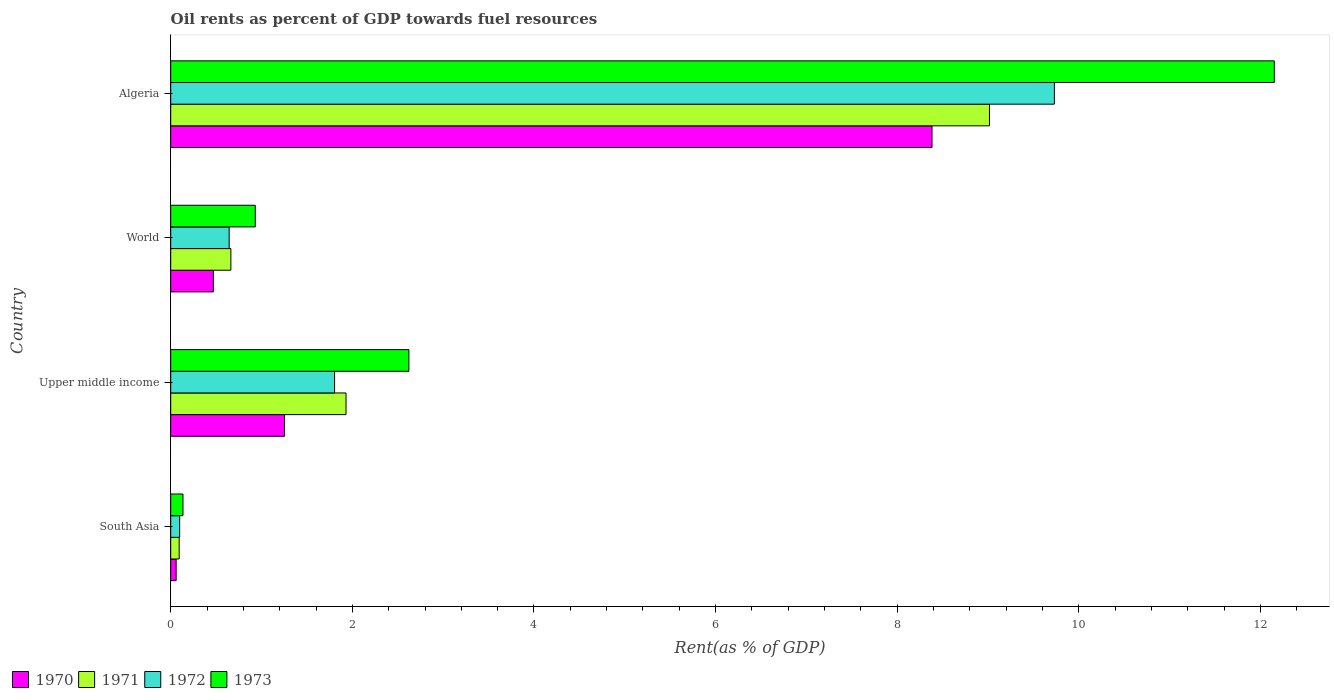Are the number of bars on each tick of the Y-axis equal?
Give a very brief answer. Yes. How many bars are there on the 4th tick from the bottom?
Your answer should be very brief. 4. What is the label of the 1st group of bars from the top?
Offer a terse response. Algeria. In how many cases, is the number of bars for a given country not equal to the number of legend labels?
Make the answer very short. 0. What is the oil rent in 1971 in World?
Make the answer very short. 0.66. Across all countries, what is the maximum oil rent in 1972?
Your answer should be very brief. 9.73. Across all countries, what is the minimum oil rent in 1973?
Ensure brevity in your answer.  0.14. In which country was the oil rent in 1970 maximum?
Keep it short and to the point. Algeria. What is the total oil rent in 1970 in the graph?
Offer a terse response. 10.17. What is the difference between the oil rent in 1971 in South Asia and that in World?
Provide a succinct answer. -0.57. What is the difference between the oil rent in 1971 in World and the oil rent in 1973 in Upper middle income?
Your response must be concise. -1.96. What is the average oil rent in 1973 per country?
Ensure brevity in your answer.  3.96. What is the difference between the oil rent in 1972 and oil rent in 1973 in Upper middle income?
Provide a short and direct response. -0.82. In how many countries, is the oil rent in 1970 greater than 10 %?
Offer a terse response. 0. What is the ratio of the oil rent in 1973 in Algeria to that in World?
Your answer should be very brief. 13.05. Is the difference between the oil rent in 1972 in South Asia and World greater than the difference between the oil rent in 1973 in South Asia and World?
Offer a very short reply. Yes. What is the difference between the highest and the second highest oil rent in 1971?
Keep it short and to the point. 7.09. What is the difference between the highest and the lowest oil rent in 1972?
Your response must be concise. 9.63. Is the sum of the oil rent in 1971 in South Asia and World greater than the maximum oil rent in 1972 across all countries?
Give a very brief answer. No. What does the 1st bar from the top in World represents?
Offer a terse response. 1973. How many bars are there?
Provide a succinct answer. 16. How many countries are there in the graph?
Your response must be concise. 4. Where does the legend appear in the graph?
Provide a short and direct response. Bottom left. How many legend labels are there?
Keep it short and to the point. 4. How are the legend labels stacked?
Keep it short and to the point. Horizontal. What is the title of the graph?
Offer a terse response. Oil rents as percent of GDP towards fuel resources. What is the label or title of the X-axis?
Make the answer very short. Rent(as % of GDP). What is the label or title of the Y-axis?
Your answer should be compact. Country. What is the Rent(as % of GDP) of 1970 in South Asia?
Offer a terse response. 0.06. What is the Rent(as % of GDP) in 1971 in South Asia?
Provide a short and direct response. 0.09. What is the Rent(as % of GDP) of 1972 in South Asia?
Give a very brief answer. 0.1. What is the Rent(as % of GDP) in 1973 in South Asia?
Provide a short and direct response. 0.14. What is the Rent(as % of GDP) in 1970 in Upper middle income?
Your answer should be very brief. 1.25. What is the Rent(as % of GDP) in 1971 in Upper middle income?
Make the answer very short. 1.93. What is the Rent(as % of GDP) in 1972 in Upper middle income?
Your answer should be compact. 1.8. What is the Rent(as % of GDP) in 1973 in Upper middle income?
Give a very brief answer. 2.62. What is the Rent(as % of GDP) in 1970 in World?
Give a very brief answer. 0.47. What is the Rent(as % of GDP) of 1971 in World?
Your answer should be very brief. 0.66. What is the Rent(as % of GDP) in 1972 in World?
Your answer should be compact. 0.64. What is the Rent(as % of GDP) of 1973 in World?
Your response must be concise. 0.93. What is the Rent(as % of GDP) of 1970 in Algeria?
Offer a very short reply. 8.38. What is the Rent(as % of GDP) in 1971 in Algeria?
Offer a terse response. 9.02. What is the Rent(as % of GDP) of 1972 in Algeria?
Offer a very short reply. 9.73. What is the Rent(as % of GDP) of 1973 in Algeria?
Your answer should be very brief. 12.15. Across all countries, what is the maximum Rent(as % of GDP) in 1970?
Your response must be concise. 8.38. Across all countries, what is the maximum Rent(as % of GDP) in 1971?
Make the answer very short. 9.02. Across all countries, what is the maximum Rent(as % of GDP) of 1972?
Keep it short and to the point. 9.73. Across all countries, what is the maximum Rent(as % of GDP) of 1973?
Make the answer very short. 12.15. Across all countries, what is the minimum Rent(as % of GDP) in 1970?
Make the answer very short. 0.06. Across all countries, what is the minimum Rent(as % of GDP) of 1971?
Ensure brevity in your answer.  0.09. Across all countries, what is the minimum Rent(as % of GDP) of 1972?
Your answer should be compact. 0.1. Across all countries, what is the minimum Rent(as % of GDP) in 1973?
Provide a succinct answer. 0.14. What is the total Rent(as % of GDP) of 1970 in the graph?
Offer a terse response. 10.17. What is the total Rent(as % of GDP) in 1971 in the graph?
Make the answer very short. 11.7. What is the total Rent(as % of GDP) of 1972 in the graph?
Your answer should be compact. 12.28. What is the total Rent(as % of GDP) in 1973 in the graph?
Your answer should be compact. 15.84. What is the difference between the Rent(as % of GDP) in 1970 in South Asia and that in Upper middle income?
Ensure brevity in your answer.  -1.19. What is the difference between the Rent(as % of GDP) of 1971 in South Asia and that in Upper middle income?
Your answer should be compact. -1.84. What is the difference between the Rent(as % of GDP) of 1972 in South Asia and that in Upper middle income?
Make the answer very short. -1.71. What is the difference between the Rent(as % of GDP) in 1973 in South Asia and that in Upper middle income?
Your answer should be compact. -2.49. What is the difference between the Rent(as % of GDP) of 1970 in South Asia and that in World?
Ensure brevity in your answer.  -0.41. What is the difference between the Rent(as % of GDP) of 1971 in South Asia and that in World?
Provide a short and direct response. -0.57. What is the difference between the Rent(as % of GDP) in 1972 in South Asia and that in World?
Provide a succinct answer. -0.55. What is the difference between the Rent(as % of GDP) of 1973 in South Asia and that in World?
Your response must be concise. -0.8. What is the difference between the Rent(as % of GDP) of 1970 in South Asia and that in Algeria?
Ensure brevity in your answer.  -8.32. What is the difference between the Rent(as % of GDP) of 1971 in South Asia and that in Algeria?
Provide a succinct answer. -8.92. What is the difference between the Rent(as % of GDP) of 1972 in South Asia and that in Algeria?
Make the answer very short. -9.63. What is the difference between the Rent(as % of GDP) in 1973 in South Asia and that in Algeria?
Give a very brief answer. -12.02. What is the difference between the Rent(as % of GDP) of 1970 in Upper middle income and that in World?
Keep it short and to the point. 0.78. What is the difference between the Rent(as % of GDP) in 1971 in Upper middle income and that in World?
Provide a short and direct response. 1.27. What is the difference between the Rent(as % of GDP) of 1972 in Upper middle income and that in World?
Give a very brief answer. 1.16. What is the difference between the Rent(as % of GDP) of 1973 in Upper middle income and that in World?
Your response must be concise. 1.69. What is the difference between the Rent(as % of GDP) of 1970 in Upper middle income and that in Algeria?
Provide a short and direct response. -7.13. What is the difference between the Rent(as % of GDP) in 1971 in Upper middle income and that in Algeria?
Your answer should be very brief. -7.09. What is the difference between the Rent(as % of GDP) of 1972 in Upper middle income and that in Algeria?
Keep it short and to the point. -7.93. What is the difference between the Rent(as % of GDP) of 1973 in Upper middle income and that in Algeria?
Provide a succinct answer. -9.53. What is the difference between the Rent(as % of GDP) of 1970 in World and that in Algeria?
Your answer should be very brief. -7.91. What is the difference between the Rent(as % of GDP) of 1971 in World and that in Algeria?
Offer a very short reply. -8.35. What is the difference between the Rent(as % of GDP) in 1972 in World and that in Algeria?
Keep it short and to the point. -9.09. What is the difference between the Rent(as % of GDP) of 1973 in World and that in Algeria?
Provide a short and direct response. -11.22. What is the difference between the Rent(as % of GDP) of 1970 in South Asia and the Rent(as % of GDP) of 1971 in Upper middle income?
Your answer should be very brief. -1.87. What is the difference between the Rent(as % of GDP) of 1970 in South Asia and the Rent(as % of GDP) of 1972 in Upper middle income?
Your answer should be very brief. -1.74. What is the difference between the Rent(as % of GDP) of 1970 in South Asia and the Rent(as % of GDP) of 1973 in Upper middle income?
Keep it short and to the point. -2.56. What is the difference between the Rent(as % of GDP) in 1971 in South Asia and the Rent(as % of GDP) in 1972 in Upper middle income?
Your answer should be very brief. -1.71. What is the difference between the Rent(as % of GDP) in 1971 in South Asia and the Rent(as % of GDP) in 1973 in Upper middle income?
Ensure brevity in your answer.  -2.53. What is the difference between the Rent(as % of GDP) in 1972 in South Asia and the Rent(as % of GDP) in 1973 in Upper middle income?
Provide a succinct answer. -2.52. What is the difference between the Rent(as % of GDP) of 1970 in South Asia and the Rent(as % of GDP) of 1971 in World?
Your answer should be very brief. -0.6. What is the difference between the Rent(as % of GDP) in 1970 in South Asia and the Rent(as % of GDP) in 1972 in World?
Give a very brief answer. -0.58. What is the difference between the Rent(as % of GDP) of 1970 in South Asia and the Rent(as % of GDP) of 1973 in World?
Provide a short and direct response. -0.87. What is the difference between the Rent(as % of GDP) of 1971 in South Asia and the Rent(as % of GDP) of 1972 in World?
Give a very brief answer. -0.55. What is the difference between the Rent(as % of GDP) of 1971 in South Asia and the Rent(as % of GDP) of 1973 in World?
Your answer should be compact. -0.84. What is the difference between the Rent(as % of GDP) of 1972 in South Asia and the Rent(as % of GDP) of 1973 in World?
Provide a succinct answer. -0.83. What is the difference between the Rent(as % of GDP) in 1970 in South Asia and the Rent(as % of GDP) in 1971 in Algeria?
Give a very brief answer. -8.96. What is the difference between the Rent(as % of GDP) in 1970 in South Asia and the Rent(as % of GDP) in 1972 in Algeria?
Give a very brief answer. -9.67. What is the difference between the Rent(as % of GDP) of 1970 in South Asia and the Rent(as % of GDP) of 1973 in Algeria?
Provide a short and direct response. -12.09. What is the difference between the Rent(as % of GDP) of 1971 in South Asia and the Rent(as % of GDP) of 1972 in Algeria?
Keep it short and to the point. -9.64. What is the difference between the Rent(as % of GDP) in 1971 in South Asia and the Rent(as % of GDP) in 1973 in Algeria?
Offer a very short reply. -12.06. What is the difference between the Rent(as % of GDP) in 1972 in South Asia and the Rent(as % of GDP) in 1973 in Algeria?
Your response must be concise. -12.05. What is the difference between the Rent(as % of GDP) of 1970 in Upper middle income and the Rent(as % of GDP) of 1971 in World?
Keep it short and to the point. 0.59. What is the difference between the Rent(as % of GDP) of 1970 in Upper middle income and the Rent(as % of GDP) of 1972 in World?
Offer a terse response. 0.61. What is the difference between the Rent(as % of GDP) in 1970 in Upper middle income and the Rent(as % of GDP) in 1973 in World?
Ensure brevity in your answer.  0.32. What is the difference between the Rent(as % of GDP) of 1971 in Upper middle income and the Rent(as % of GDP) of 1972 in World?
Provide a succinct answer. 1.29. What is the difference between the Rent(as % of GDP) in 1972 in Upper middle income and the Rent(as % of GDP) in 1973 in World?
Provide a short and direct response. 0.87. What is the difference between the Rent(as % of GDP) of 1970 in Upper middle income and the Rent(as % of GDP) of 1971 in Algeria?
Give a very brief answer. -7.76. What is the difference between the Rent(as % of GDP) of 1970 in Upper middle income and the Rent(as % of GDP) of 1972 in Algeria?
Your response must be concise. -8.48. What is the difference between the Rent(as % of GDP) of 1970 in Upper middle income and the Rent(as % of GDP) of 1973 in Algeria?
Provide a succinct answer. -10.9. What is the difference between the Rent(as % of GDP) in 1971 in Upper middle income and the Rent(as % of GDP) in 1972 in Algeria?
Ensure brevity in your answer.  -7.8. What is the difference between the Rent(as % of GDP) of 1971 in Upper middle income and the Rent(as % of GDP) of 1973 in Algeria?
Your answer should be compact. -10.22. What is the difference between the Rent(as % of GDP) in 1972 in Upper middle income and the Rent(as % of GDP) in 1973 in Algeria?
Provide a short and direct response. -10.35. What is the difference between the Rent(as % of GDP) in 1970 in World and the Rent(as % of GDP) in 1971 in Algeria?
Ensure brevity in your answer.  -8.55. What is the difference between the Rent(as % of GDP) of 1970 in World and the Rent(as % of GDP) of 1972 in Algeria?
Offer a very short reply. -9.26. What is the difference between the Rent(as % of GDP) in 1970 in World and the Rent(as % of GDP) in 1973 in Algeria?
Keep it short and to the point. -11.68. What is the difference between the Rent(as % of GDP) in 1971 in World and the Rent(as % of GDP) in 1972 in Algeria?
Offer a very short reply. -9.07. What is the difference between the Rent(as % of GDP) of 1971 in World and the Rent(as % of GDP) of 1973 in Algeria?
Your answer should be very brief. -11.49. What is the difference between the Rent(as % of GDP) of 1972 in World and the Rent(as % of GDP) of 1973 in Algeria?
Give a very brief answer. -11.51. What is the average Rent(as % of GDP) in 1970 per country?
Provide a succinct answer. 2.54. What is the average Rent(as % of GDP) of 1971 per country?
Ensure brevity in your answer.  2.93. What is the average Rent(as % of GDP) in 1972 per country?
Your answer should be very brief. 3.07. What is the average Rent(as % of GDP) in 1973 per country?
Offer a very short reply. 3.96. What is the difference between the Rent(as % of GDP) of 1970 and Rent(as % of GDP) of 1971 in South Asia?
Make the answer very short. -0.03. What is the difference between the Rent(as % of GDP) in 1970 and Rent(as % of GDP) in 1972 in South Asia?
Ensure brevity in your answer.  -0.04. What is the difference between the Rent(as % of GDP) of 1970 and Rent(as % of GDP) of 1973 in South Asia?
Your response must be concise. -0.08. What is the difference between the Rent(as % of GDP) of 1971 and Rent(as % of GDP) of 1972 in South Asia?
Your answer should be compact. -0.01. What is the difference between the Rent(as % of GDP) of 1971 and Rent(as % of GDP) of 1973 in South Asia?
Your answer should be very brief. -0.04. What is the difference between the Rent(as % of GDP) in 1972 and Rent(as % of GDP) in 1973 in South Asia?
Your answer should be compact. -0.04. What is the difference between the Rent(as % of GDP) in 1970 and Rent(as % of GDP) in 1971 in Upper middle income?
Keep it short and to the point. -0.68. What is the difference between the Rent(as % of GDP) in 1970 and Rent(as % of GDP) in 1972 in Upper middle income?
Ensure brevity in your answer.  -0.55. What is the difference between the Rent(as % of GDP) in 1970 and Rent(as % of GDP) in 1973 in Upper middle income?
Offer a very short reply. -1.37. What is the difference between the Rent(as % of GDP) of 1971 and Rent(as % of GDP) of 1972 in Upper middle income?
Keep it short and to the point. 0.13. What is the difference between the Rent(as % of GDP) in 1971 and Rent(as % of GDP) in 1973 in Upper middle income?
Provide a succinct answer. -0.69. What is the difference between the Rent(as % of GDP) of 1972 and Rent(as % of GDP) of 1973 in Upper middle income?
Offer a terse response. -0.82. What is the difference between the Rent(as % of GDP) of 1970 and Rent(as % of GDP) of 1971 in World?
Make the answer very short. -0.19. What is the difference between the Rent(as % of GDP) of 1970 and Rent(as % of GDP) of 1972 in World?
Keep it short and to the point. -0.17. What is the difference between the Rent(as % of GDP) in 1970 and Rent(as % of GDP) in 1973 in World?
Provide a succinct answer. -0.46. What is the difference between the Rent(as % of GDP) of 1971 and Rent(as % of GDP) of 1972 in World?
Keep it short and to the point. 0.02. What is the difference between the Rent(as % of GDP) of 1971 and Rent(as % of GDP) of 1973 in World?
Your answer should be very brief. -0.27. What is the difference between the Rent(as % of GDP) of 1972 and Rent(as % of GDP) of 1973 in World?
Make the answer very short. -0.29. What is the difference between the Rent(as % of GDP) in 1970 and Rent(as % of GDP) in 1971 in Algeria?
Your response must be concise. -0.63. What is the difference between the Rent(as % of GDP) in 1970 and Rent(as % of GDP) in 1972 in Algeria?
Offer a very short reply. -1.35. What is the difference between the Rent(as % of GDP) of 1970 and Rent(as % of GDP) of 1973 in Algeria?
Your response must be concise. -3.77. What is the difference between the Rent(as % of GDP) in 1971 and Rent(as % of GDP) in 1972 in Algeria?
Offer a terse response. -0.71. What is the difference between the Rent(as % of GDP) of 1971 and Rent(as % of GDP) of 1973 in Algeria?
Keep it short and to the point. -3.14. What is the difference between the Rent(as % of GDP) in 1972 and Rent(as % of GDP) in 1973 in Algeria?
Keep it short and to the point. -2.42. What is the ratio of the Rent(as % of GDP) of 1970 in South Asia to that in Upper middle income?
Offer a very short reply. 0.05. What is the ratio of the Rent(as % of GDP) in 1971 in South Asia to that in Upper middle income?
Your response must be concise. 0.05. What is the ratio of the Rent(as % of GDP) in 1972 in South Asia to that in Upper middle income?
Offer a terse response. 0.05. What is the ratio of the Rent(as % of GDP) of 1973 in South Asia to that in Upper middle income?
Give a very brief answer. 0.05. What is the ratio of the Rent(as % of GDP) of 1970 in South Asia to that in World?
Provide a short and direct response. 0.13. What is the ratio of the Rent(as % of GDP) in 1971 in South Asia to that in World?
Provide a succinct answer. 0.14. What is the ratio of the Rent(as % of GDP) in 1972 in South Asia to that in World?
Keep it short and to the point. 0.15. What is the ratio of the Rent(as % of GDP) of 1973 in South Asia to that in World?
Give a very brief answer. 0.14. What is the ratio of the Rent(as % of GDP) of 1970 in South Asia to that in Algeria?
Offer a very short reply. 0.01. What is the ratio of the Rent(as % of GDP) of 1971 in South Asia to that in Algeria?
Offer a terse response. 0.01. What is the ratio of the Rent(as % of GDP) in 1972 in South Asia to that in Algeria?
Provide a succinct answer. 0.01. What is the ratio of the Rent(as % of GDP) in 1973 in South Asia to that in Algeria?
Provide a short and direct response. 0.01. What is the ratio of the Rent(as % of GDP) in 1970 in Upper middle income to that in World?
Your answer should be compact. 2.67. What is the ratio of the Rent(as % of GDP) in 1971 in Upper middle income to that in World?
Offer a terse response. 2.91. What is the ratio of the Rent(as % of GDP) of 1972 in Upper middle income to that in World?
Ensure brevity in your answer.  2.8. What is the ratio of the Rent(as % of GDP) of 1973 in Upper middle income to that in World?
Provide a succinct answer. 2.82. What is the ratio of the Rent(as % of GDP) of 1970 in Upper middle income to that in Algeria?
Your answer should be very brief. 0.15. What is the ratio of the Rent(as % of GDP) of 1971 in Upper middle income to that in Algeria?
Your response must be concise. 0.21. What is the ratio of the Rent(as % of GDP) of 1972 in Upper middle income to that in Algeria?
Keep it short and to the point. 0.19. What is the ratio of the Rent(as % of GDP) in 1973 in Upper middle income to that in Algeria?
Your response must be concise. 0.22. What is the ratio of the Rent(as % of GDP) in 1970 in World to that in Algeria?
Offer a terse response. 0.06. What is the ratio of the Rent(as % of GDP) of 1971 in World to that in Algeria?
Provide a short and direct response. 0.07. What is the ratio of the Rent(as % of GDP) in 1972 in World to that in Algeria?
Your answer should be compact. 0.07. What is the ratio of the Rent(as % of GDP) of 1973 in World to that in Algeria?
Your answer should be compact. 0.08. What is the difference between the highest and the second highest Rent(as % of GDP) in 1970?
Make the answer very short. 7.13. What is the difference between the highest and the second highest Rent(as % of GDP) in 1971?
Provide a succinct answer. 7.09. What is the difference between the highest and the second highest Rent(as % of GDP) in 1972?
Offer a terse response. 7.93. What is the difference between the highest and the second highest Rent(as % of GDP) in 1973?
Provide a succinct answer. 9.53. What is the difference between the highest and the lowest Rent(as % of GDP) of 1970?
Offer a very short reply. 8.32. What is the difference between the highest and the lowest Rent(as % of GDP) of 1971?
Make the answer very short. 8.92. What is the difference between the highest and the lowest Rent(as % of GDP) in 1972?
Your response must be concise. 9.63. What is the difference between the highest and the lowest Rent(as % of GDP) of 1973?
Provide a short and direct response. 12.02. 